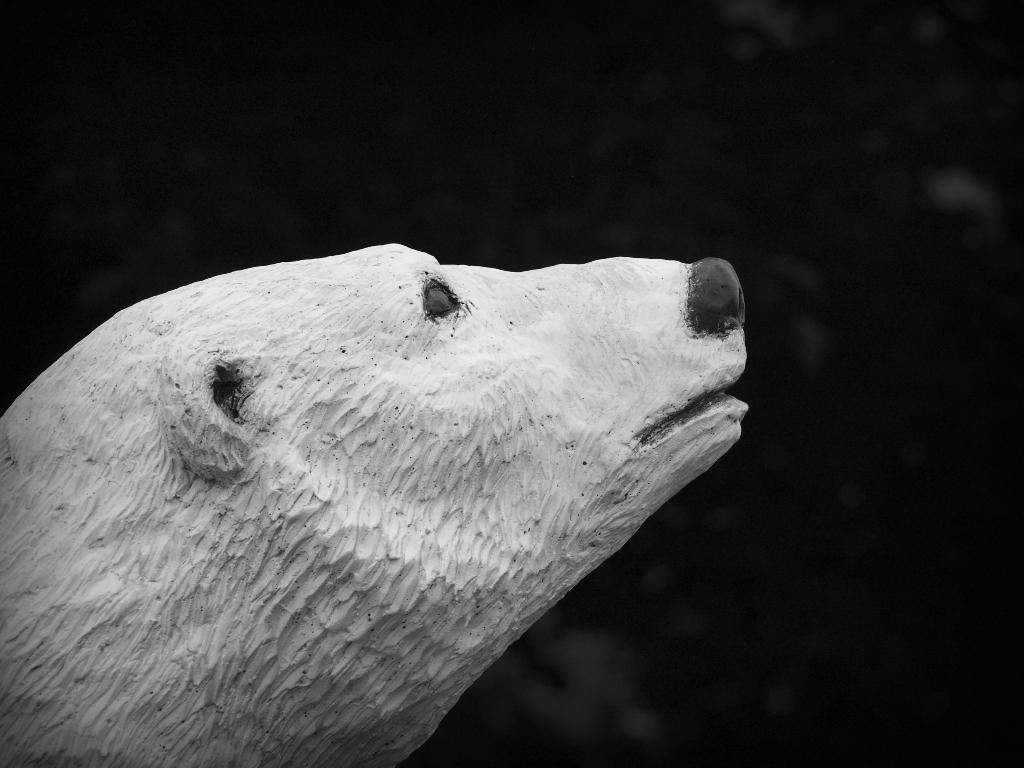What is the main subject of the image? There is a statue of an animal in the image. What can be observed about the background of the image? The background of the image is dark. What type of plastic material is used to make the pie in the image? There is no pie present in the image, and therefore no plastic material can be associated with it. 